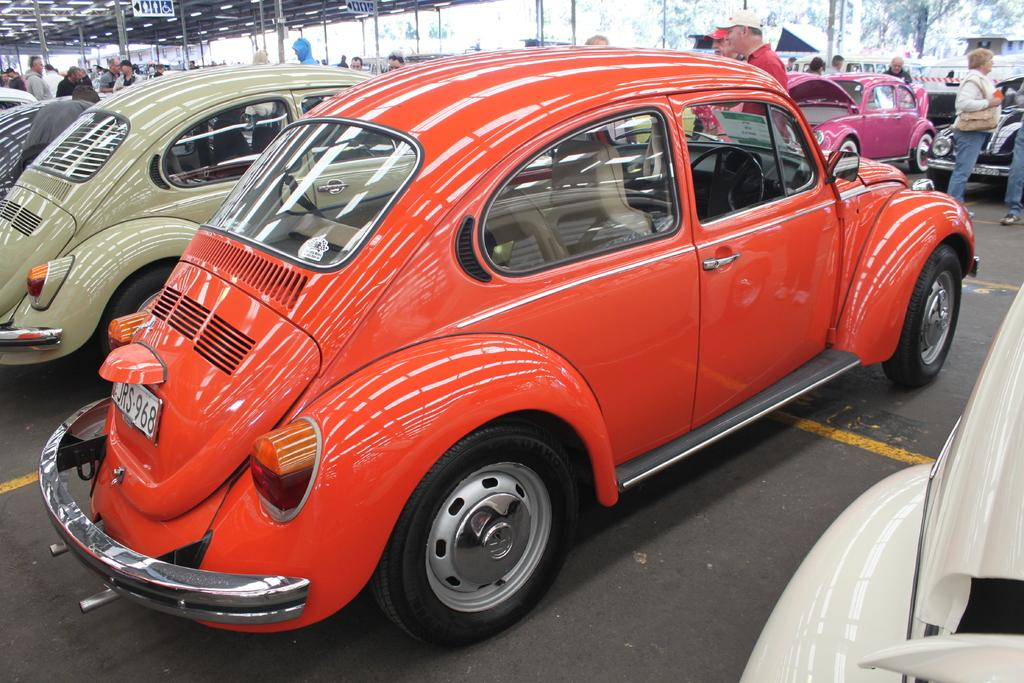What is the main subject of the image? The main subject of the image is vehicles. Can you describe the colors of some of the vehicles? Some vehicles in the image are orange and gray in color. What else can be seen in the background of the image? There are other persons standing in the background of the image. How would you describe the sky in the image? The sky is visible in the image and appears to be white in color. How many dimes are scattered on the ground in the image? There are no dimes present in the image. Are there any yaks visible in the image? There are no yaks present in the image. 